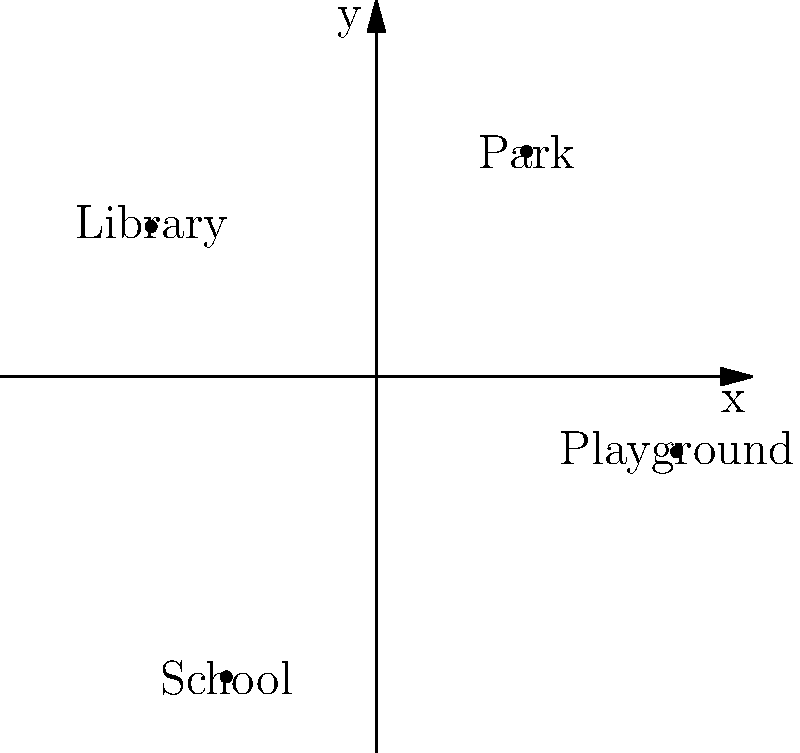On this family-friendly coordinate grid, which landmark is located in the third quadrant? To solve this problem, let's follow these steps:

1. Recall the quadrants of the coordinate plane:
   - Quadrant I: (+x, +y)
   - Quadrant II: (-x, +y)
   - Quadrant III: (-x, -y)
   - Quadrant IV: (+x, -y)

2. Identify the landmarks and their coordinates:
   - Park: (2, 3) - Quadrant I
   - Library: (-3, 2) - Quadrant II
   - School: (-2, -4) - Quadrant III
   - Playground: (4, -1) - Quadrant IV

3. The third quadrant is where both x and y coordinates are negative.

4. Looking at the coordinates, we can see that the School (-2, -4) is the only landmark in the third quadrant.
Answer: School 